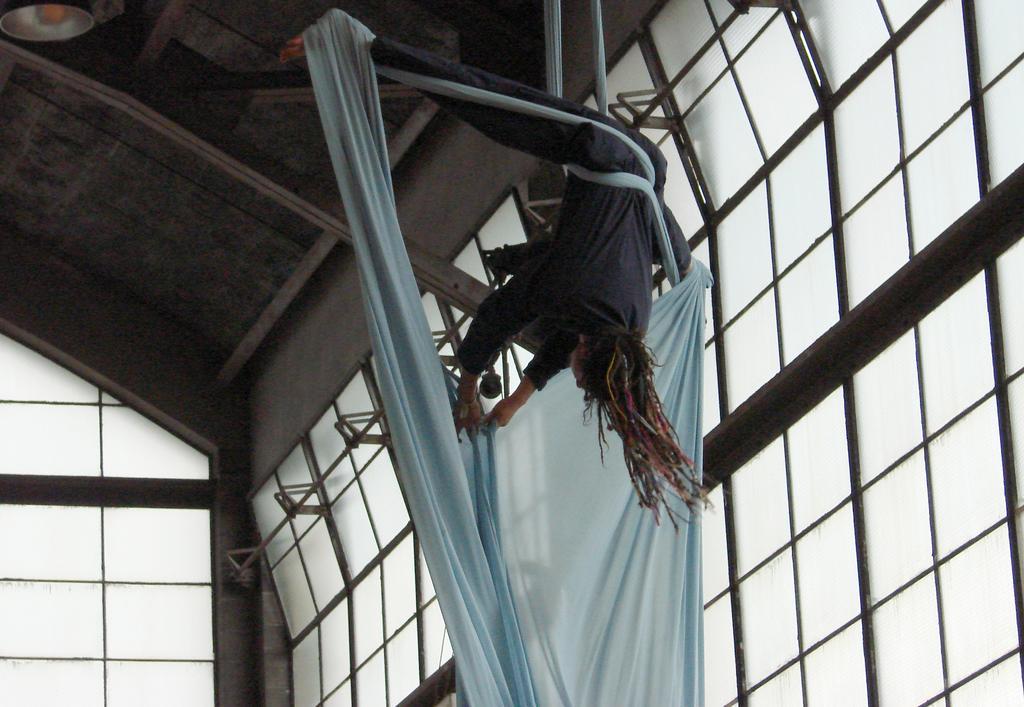Please provide a concise description of this image. A person is performing aerial acrobatics. On the sides there are glass windows. Also there is a ceiling. 